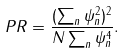<formula> <loc_0><loc_0><loc_500><loc_500>P R = \frac { ( \sum _ { n } \psi _ { n } ^ { 2 } ) ^ { 2 } } { N \sum _ { n } \psi _ { n } ^ { 4 } } .</formula> 